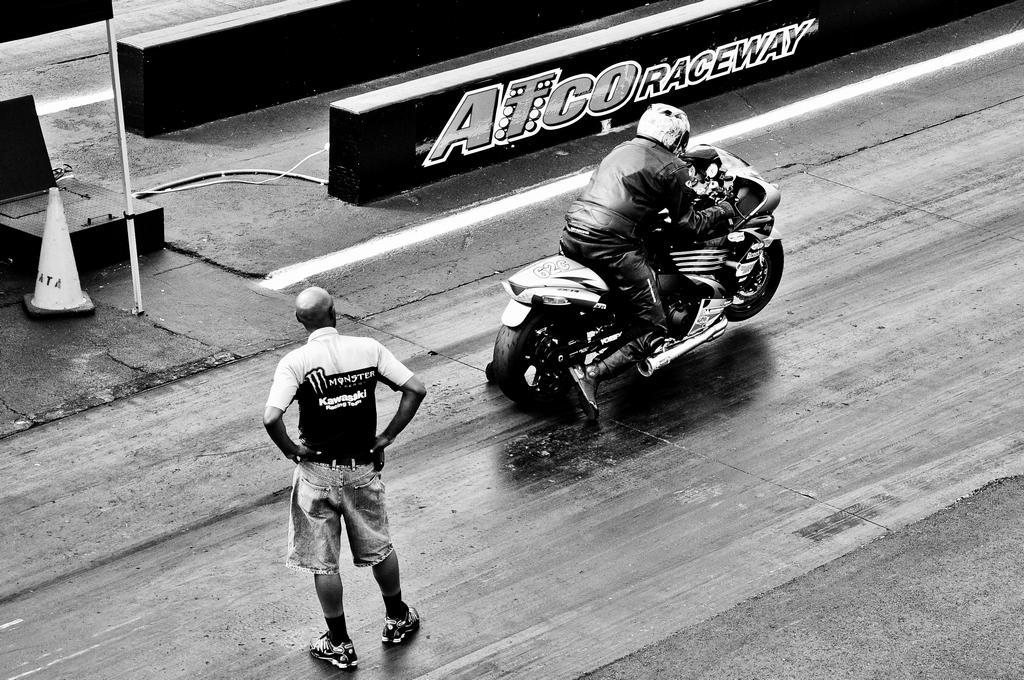Please provide a concise description of this image. In this picture there is a person standing on the road and a person is riding a bike. At the left side there is a manhole. 